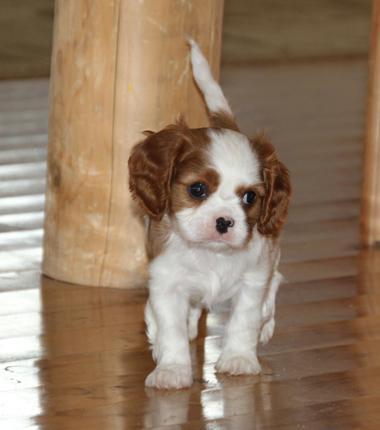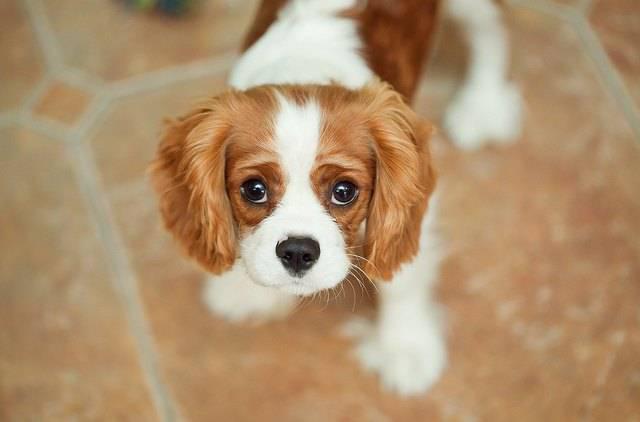The first image is the image on the left, the second image is the image on the right. Analyze the images presented: Is the assertion "There are only two puppies and neither has bows in its hair." valid? Answer yes or no. Yes. The first image is the image on the left, the second image is the image on the right. Assess this claim about the two images: "the animal in the image on the left is lying down". Correct or not? Answer yes or no. No. 